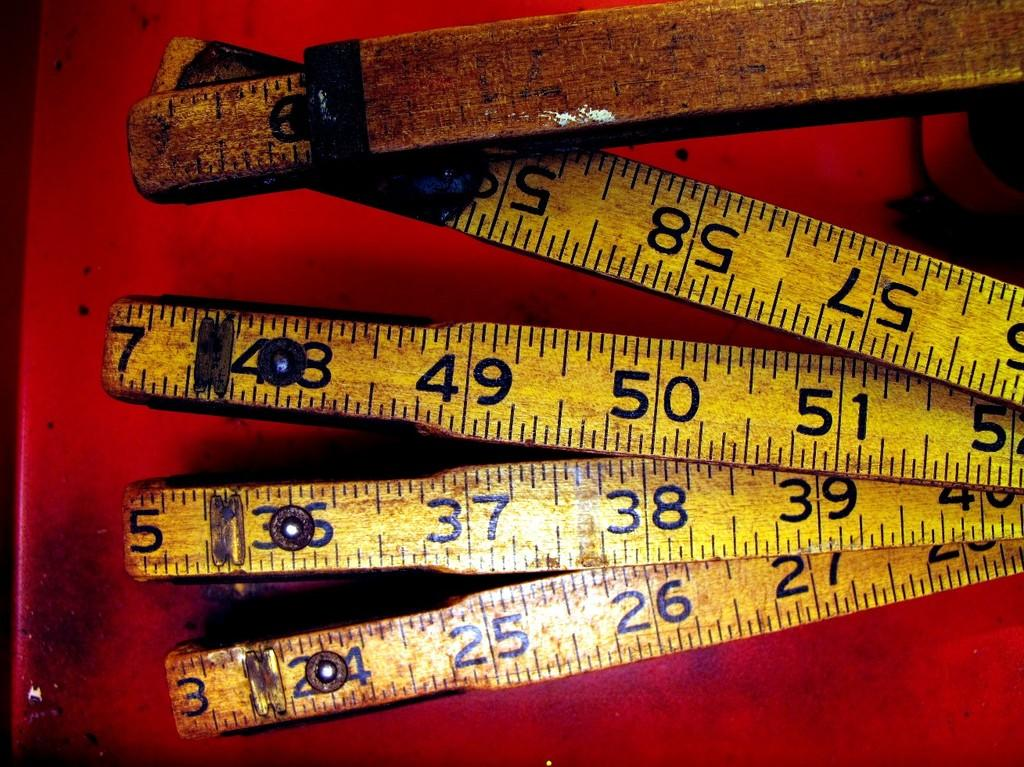<image>
Summarize the visual content of the image. An old yellow ruler is folded up and jointed at numbers 3, 5 and 7. 